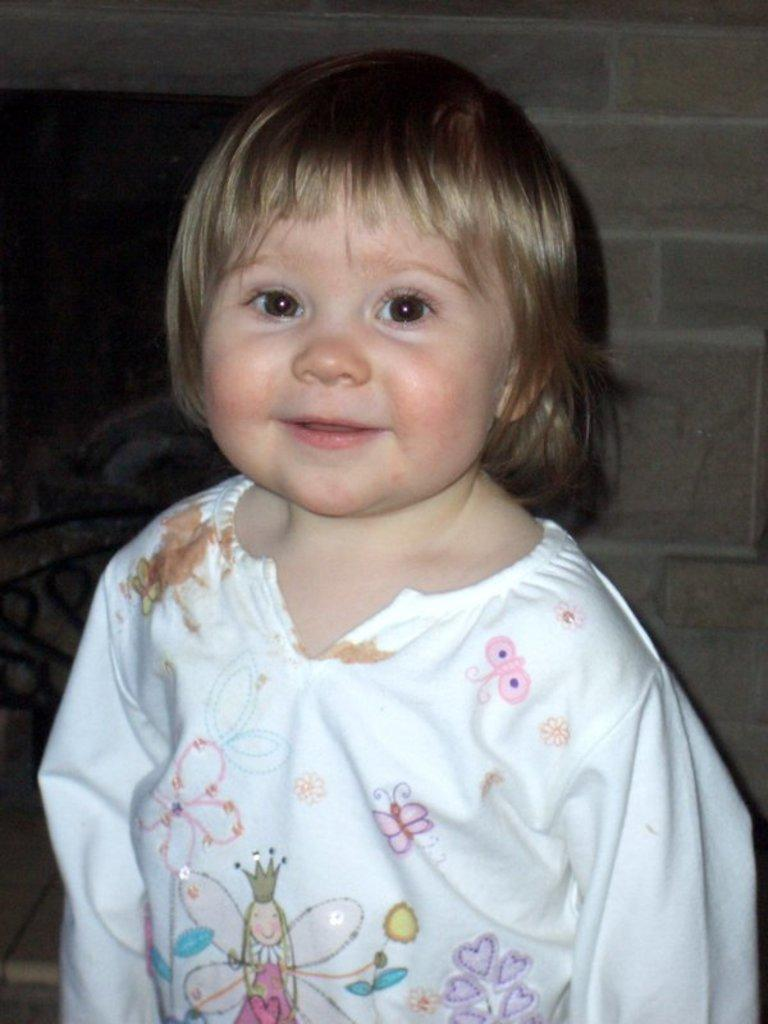Who is present in the image? There is a girl in the image. What can be seen in the background of the image? There is a wall in the background of the image. What type of flowers can be seen in the girl's bath in the image? There are no flowers or bath present in the image; it only features a girl and a wall in the background. 